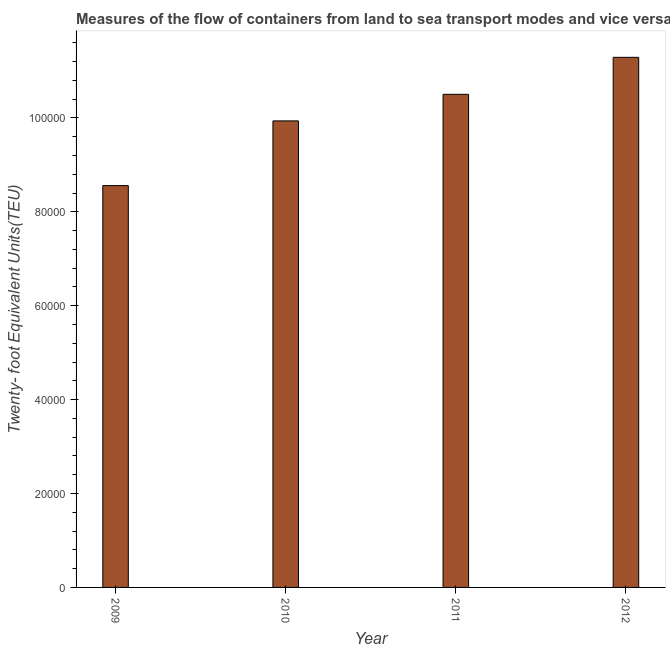Does the graph contain any zero values?
Your response must be concise. No. What is the title of the graph?
Your answer should be compact. Measures of the flow of containers from land to sea transport modes and vice versa in Brunei Darussalam. What is the label or title of the Y-axis?
Make the answer very short. Twenty- foot Equivalent Units(TEU). What is the container port traffic in 2012?
Your answer should be compact. 1.13e+05. Across all years, what is the maximum container port traffic?
Make the answer very short. 1.13e+05. Across all years, what is the minimum container port traffic?
Offer a very short reply. 8.56e+04. In which year was the container port traffic maximum?
Ensure brevity in your answer.  2012. In which year was the container port traffic minimum?
Your answer should be compact. 2009. What is the sum of the container port traffic?
Offer a terse response. 4.03e+05. What is the difference between the container port traffic in 2010 and 2012?
Make the answer very short. -1.35e+04. What is the average container port traffic per year?
Your answer should be very brief. 1.01e+05. What is the median container port traffic?
Keep it short and to the point. 1.02e+05. What is the ratio of the container port traffic in 2010 to that in 2011?
Provide a short and direct response. 0.95. What is the difference between the highest and the second highest container port traffic?
Offer a very short reply. 7876.36. Is the sum of the container port traffic in 2009 and 2010 greater than the maximum container port traffic across all years?
Provide a short and direct response. Yes. What is the difference between the highest and the lowest container port traffic?
Keep it short and to the point. 2.73e+04. In how many years, is the container port traffic greater than the average container port traffic taken over all years?
Make the answer very short. 2. Are all the bars in the graph horizontal?
Give a very brief answer. No. How many years are there in the graph?
Offer a very short reply. 4. What is the difference between two consecutive major ticks on the Y-axis?
Offer a very short reply. 2.00e+04. What is the Twenty- foot Equivalent Units(TEU) of 2009?
Provide a short and direct response. 8.56e+04. What is the Twenty- foot Equivalent Units(TEU) in 2010?
Offer a very short reply. 9.94e+04. What is the Twenty- foot Equivalent Units(TEU) of 2011?
Offer a very short reply. 1.05e+05. What is the Twenty- foot Equivalent Units(TEU) of 2012?
Your response must be concise. 1.13e+05. What is the difference between the Twenty- foot Equivalent Units(TEU) in 2009 and 2010?
Your response must be concise. -1.38e+04. What is the difference between the Twenty- foot Equivalent Units(TEU) in 2009 and 2011?
Offer a very short reply. -1.94e+04. What is the difference between the Twenty- foot Equivalent Units(TEU) in 2009 and 2012?
Offer a very short reply. -2.73e+04. What is the difference between the Twenty- foot Equivalent Units(TEU) in 2010 and 2011?
Give a very brief answer. -5663.23. What is the difference between the Twenty- foot Equivalent Units(TEU) in 2010 and 2012?
Ensure brevity in your answer.  -1.35e+04. What is the difference between the Twenty- foot Equivalent Units(TEU) in 2011 and 2012?
Give a very brief answer. -7876.36. What is the ratio of the Twenty- foot Equivalent Units(TEU) in 2009 to that in 2010?
Keep it short and to the point. 0.86. What is the ratio of the Twenty- foot Equivalent Units(TEU) in 2009 to that in 2011?
Give a very brief answer. 0.81. What is the ratio of the Twenty- foot Equivalent Units(TEU) in 2009 to that in 2012?
Your answer should be very brief. 0.76. What is the ratio of the Twenty- foot Equivalent Units(TEU) in 2010 to that in 2011?
Provide a short and direct response. 0.95. What is the ratio of the Twenty- foot Equivalent Units(TEU) in 2010 to that in 2012?
Your answer should be compact. 0.88. 